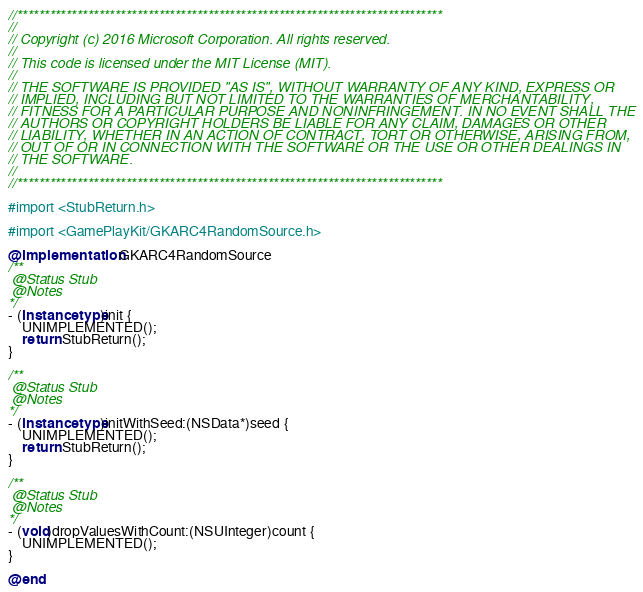<code> <loc_0><loc_0><loc_500><loc_500><_ObjectiveC_>//******************************************************************************
//
// Copyright (c) 2016 Microsoft Corporation. All rights reserved.
//
// This code is licensed under the MIT License (MIT).
//
// THE SOFTWARE IS PROVIDED "AS IS", WITHOUT WARRANTY OF ANY KIND, EXPRESS OR
// IMPLIED, INCLUDING BUT NOT LIMITED TO THE WARRANTIES OF MERCHANTABILITY,
// FITNESS FOR A PARTICULAR PURPOSE AND NONINFRINGEMENT. IN NO EVENT SHALL THE
// AUTHORS OR COPYRIGHT HOLDERS BE LIABLE FOR ANY CLAIM, DAMAGES OR OTHER
// LIABILITY, WHETHER IN AN ACTION OF CONTRACT, TORT OR OTHERWISE, ARISING FROM,
// OUT OF OR IN CONNECTION WITH THE SOFTWARE OR THE USE OR OTHER DEALINGS IN
// THE SOFTWARE.
//
//******************************************************************************

#import <StubReturn.h>

#import <GamePlayKit/GKARC4RandomSource.h>

@implementation GKARC4RandomSource
/**
 @Status Stub
 @Notes
*/
- (instancetype)init {
    UNIMPLEMENTED();
    return StubReturn();
}

/**
 @Status Stub
 @Notes
*/
- (instancetype)initWithSeed:(NSData*)seed {
    UNIMPLEMENTED();
    return StubReturn();
}

/**
 @Status Stub
 @Notes
*/
- (void)dropValuesWithCount:(NSUInteger)count {
    UNIMPLEMENTED();
}

@end
</code> 